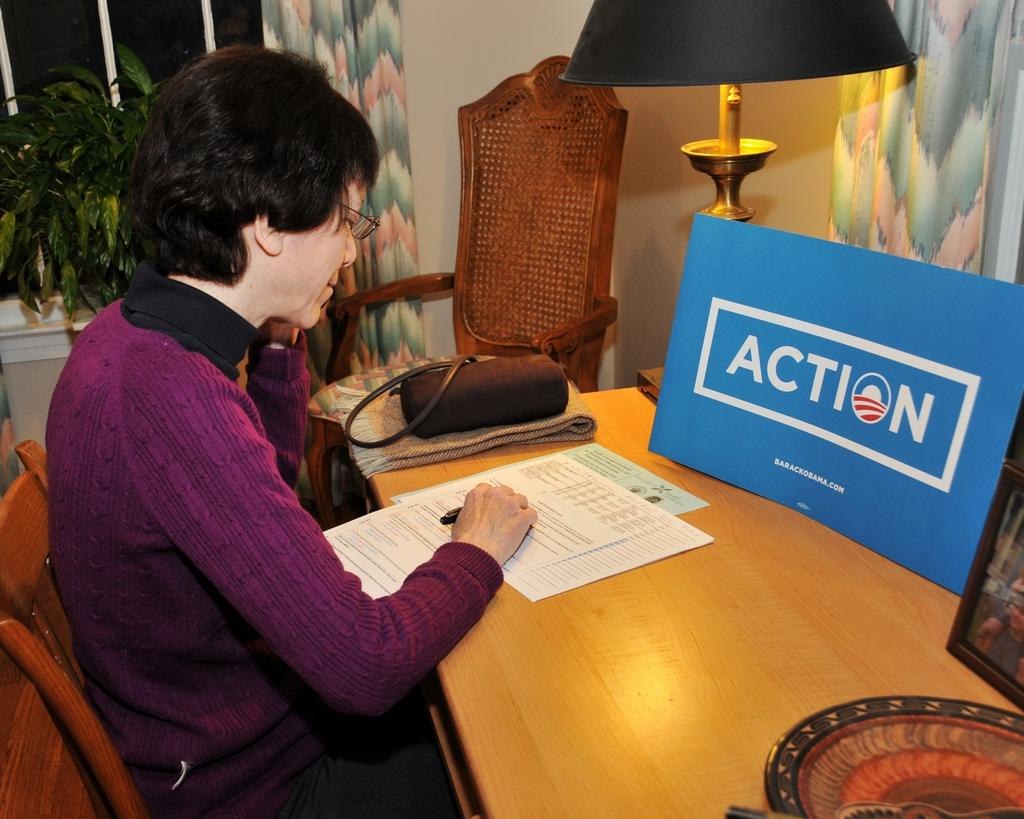<image>
Describe the image concisely. a lady in purple next to a blue auction sign 